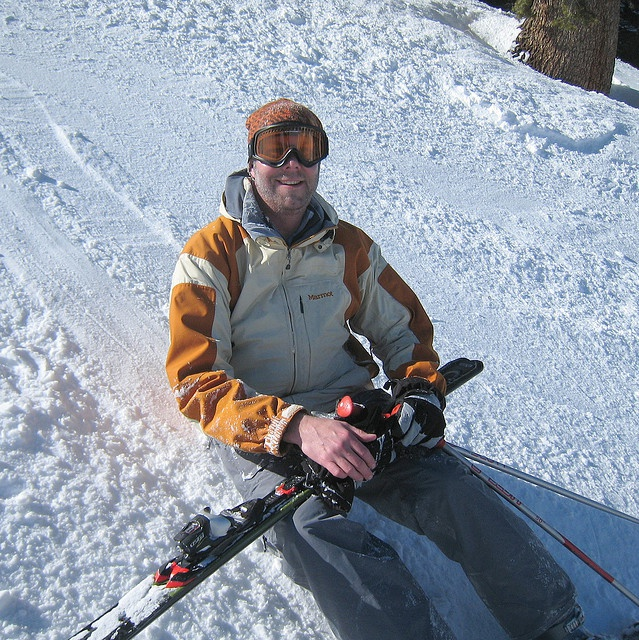Describe the objects in this image and their specific colors. I can see people in lightblue, black, gray, navy, and maroon tones and skis in lightblue, black, lightgray, and gray tones in this image. 